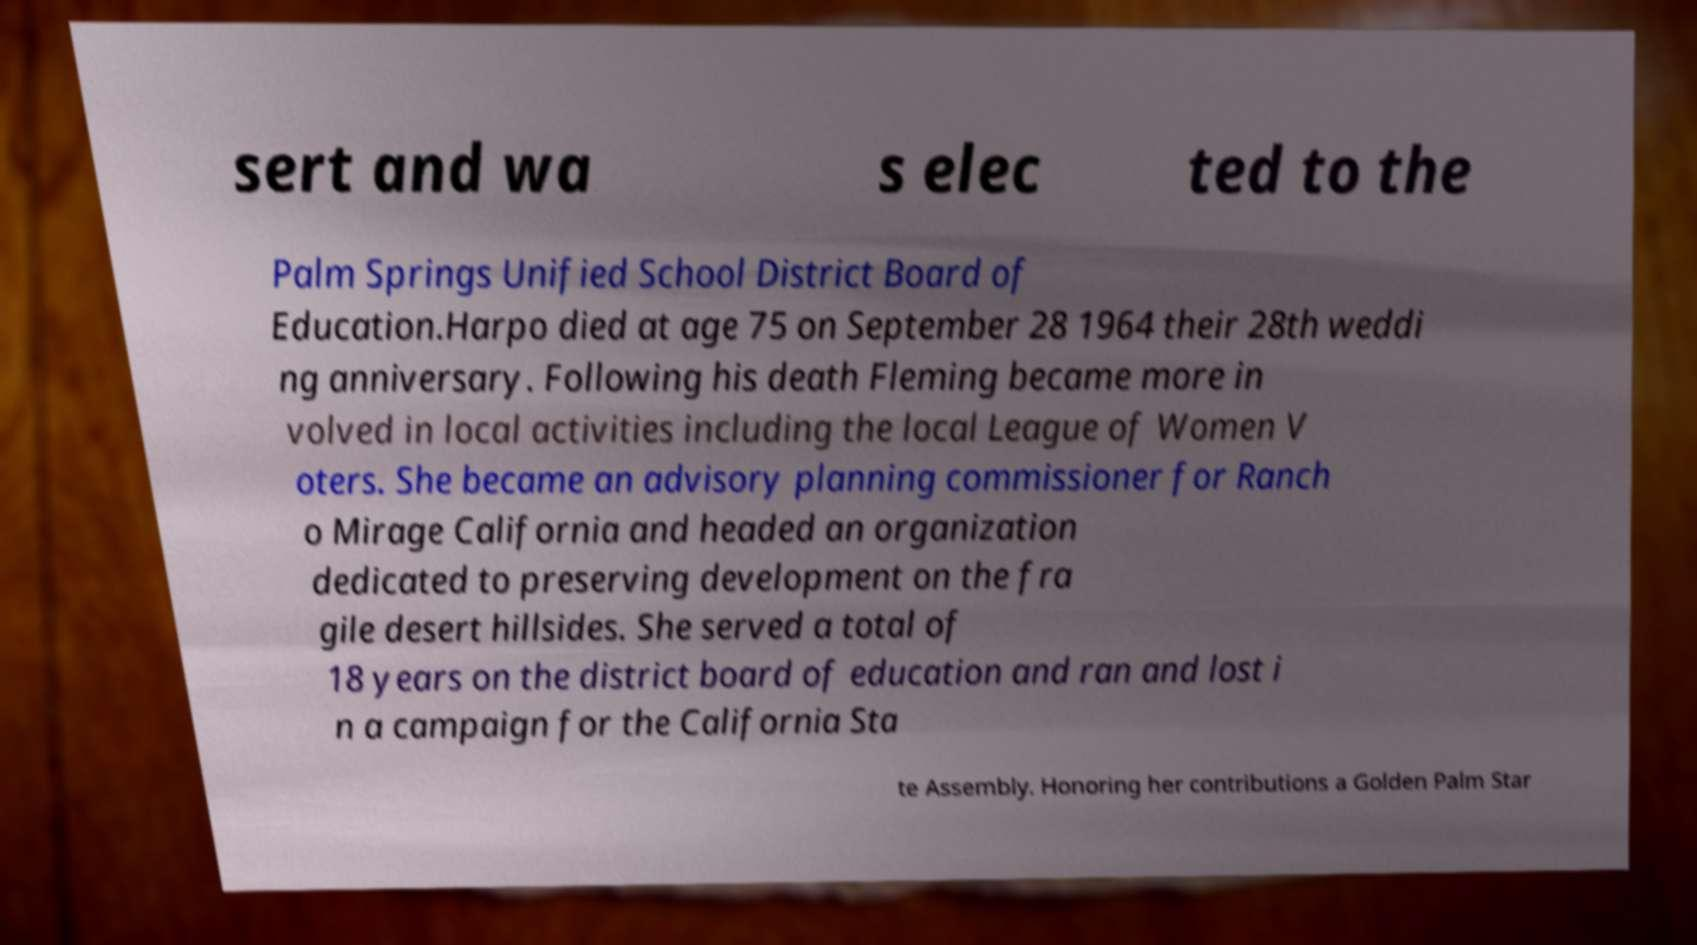Could you extract and type out the text from this image? sert and wa s elec ted to the Palm Springs Unified School District Board of Education.Harpo died at age 75 on September 28 1964 their 28th weddi ng anniversary. Following his death Fleming became more in volved in local activities including the local League of Women V oters. She became an advisory planning commissioner for Ranch o Mirage California and headed an organization dedicated to preserving development on the fra gile desert hillsides. She served a total of 18 years on the district board of education and ran and lost i n a campaign for the California Sta te Assembly. Honoring her contributions a Golden Palm Star 